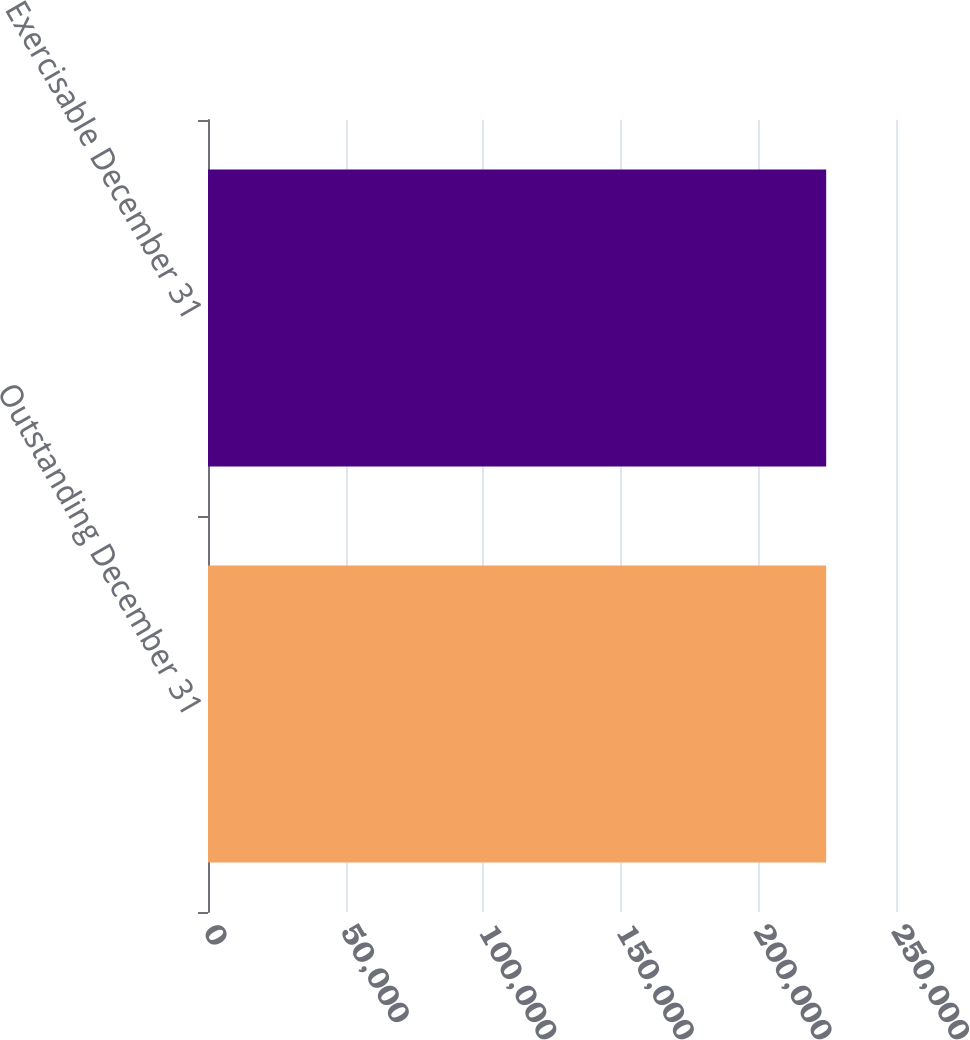<chart> <loc_0><loc_0><loc_500><loc_500><bar_chart><fcel>Outstanding December 31<fcel>Exercisable December 31<nl><fcel>224632<fcel>224632<nl></chart> 